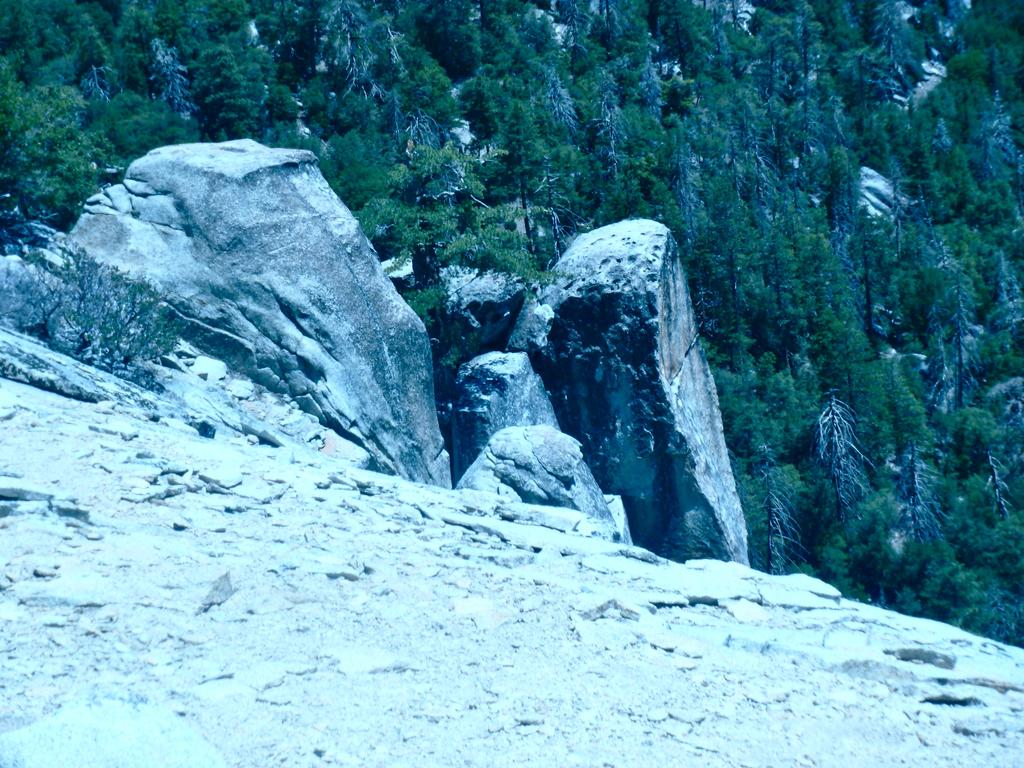What type of terrain is visible in the image? The image contains a rocky surface. What geographical features can be seen in the image? There are mountains in the image. What type of vegetation is present in the image? There are green trees in the image. How many dimes can be seen on the rocky surface in the image? There are no dimes present in the image; it features a rocky surface, mountains, and green trees. 